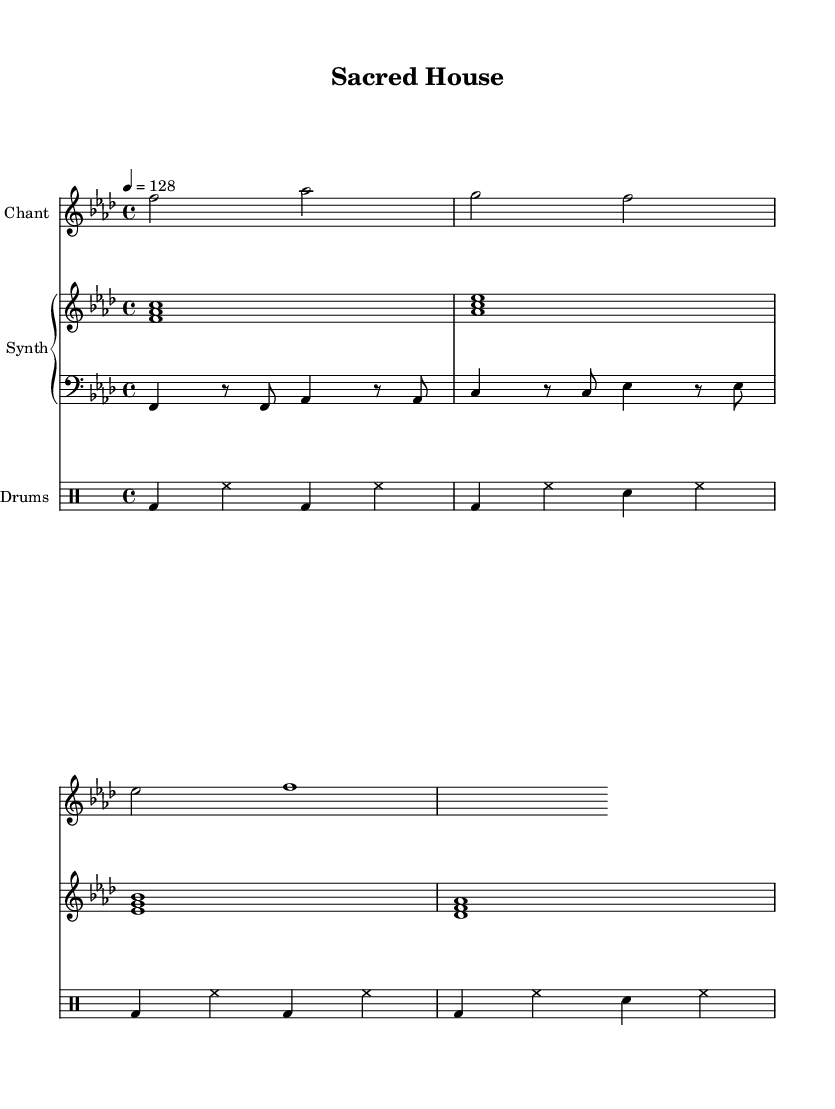What is the tempo of this piece? The tempo marking in the global section indicates that the piece is set at a speed of 128 beats per minute.
Answer: 128 What is the time signature of this music? The time signature indicated in the global section is a 4/4, which means there are four beats in each measure.
Answer: 4/4 What is the key signature of this piece? The key signature in the global section shows F minor, meaning it has four flats: B flat, E flat, A flat, and D flat.
Answer: F minor How many measures are in the chant voice section? By counting the measures in the chantVoice line, we see there are four measures.
Answer: 4 What is the main instrument used for the chanting? The clef indicated for the chantVoice is treble, assigning this part to a higher-pitched instrument or voice.
Answer: Chant Which part includes a bass line? The score shows a specific staff labeled for bass, which indicates the presence of a bass line in that instrument's section.
Answer: Bass How many different types of instruments are included in this score? There are four distinct staves for different instruments: chant, synth (piano staff), and drums, totaling to four instrument types.
Answer: 4 